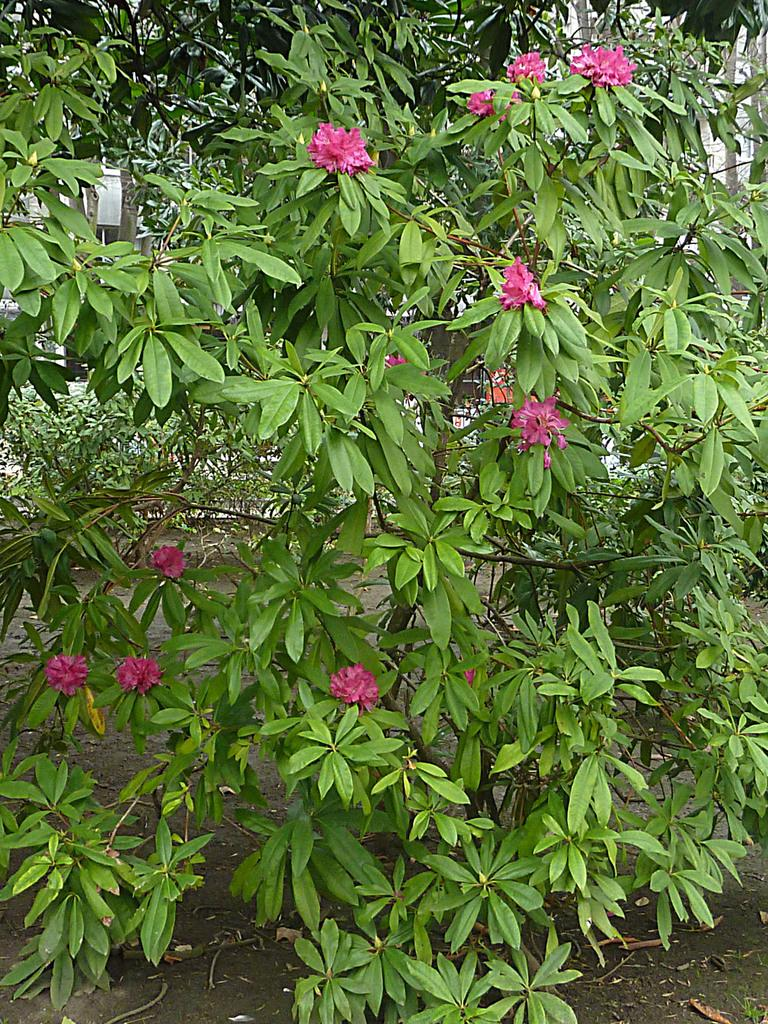What type of vegetation can be seen in the image? There are green color leaves and pink color flowers in the image. Can you describe the colors of the plants in the image? The leaves are green, and the flowers are pink. What type of bread can be seen in the image? There is no bread present in the image; it features green leaves and pink flowers. What color is the copper in the image? There is no copper present in the image. 